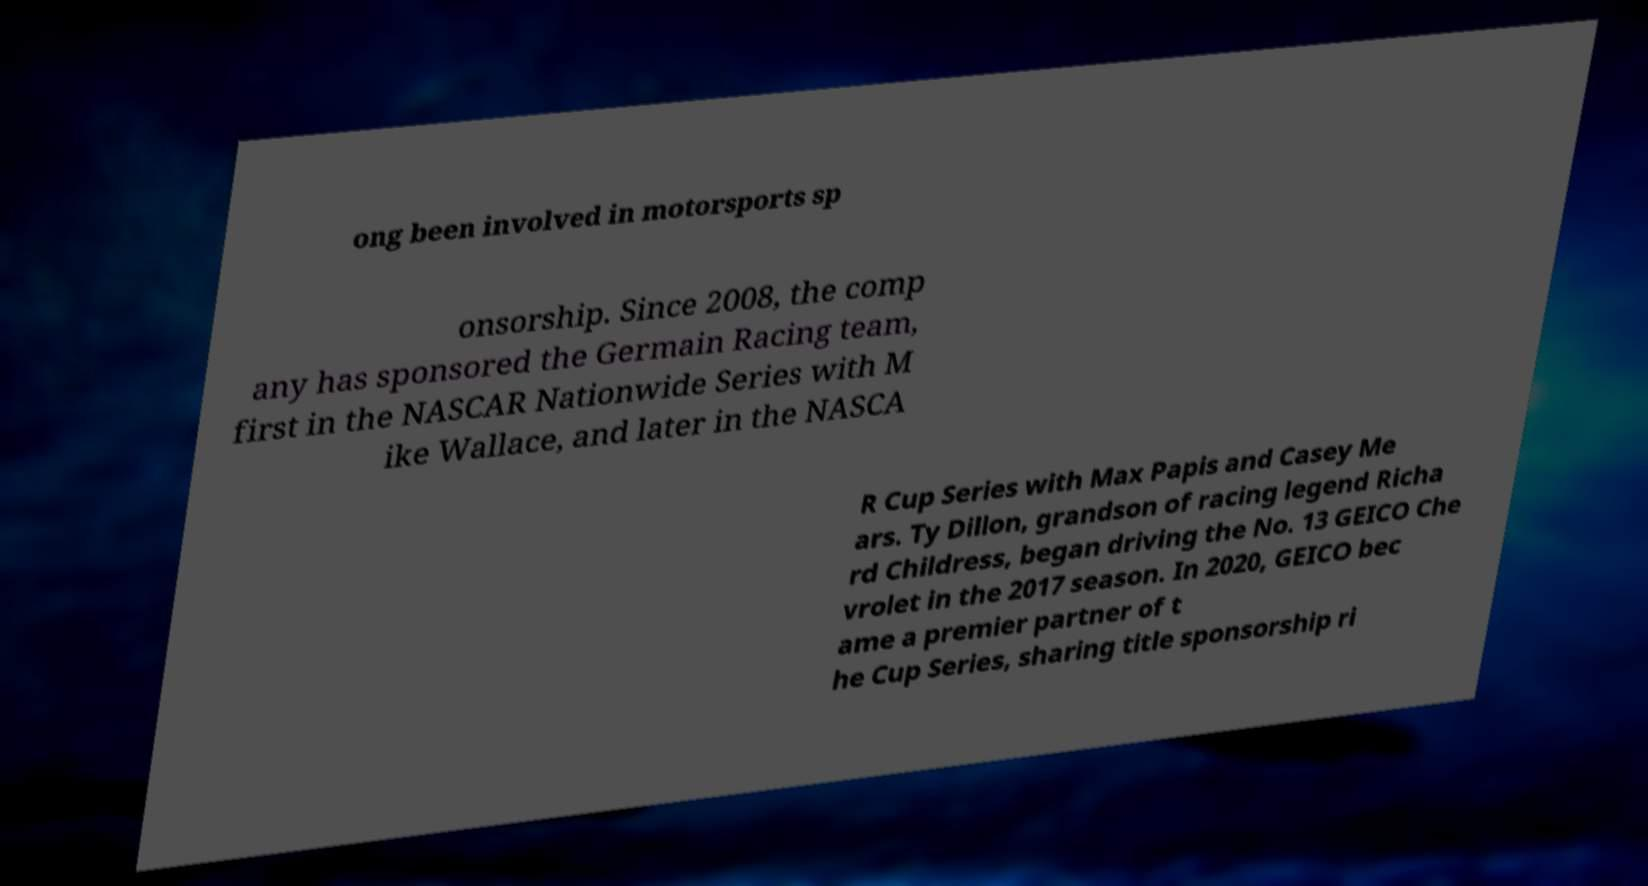Can you accurately transcribe the text from the provided image for me? ong been involved in motorsports sp onsorship. Since 2008, the comp any has sponsored the Germain Racing team, first in the NASCAR Nationwide Series with M ike Wallace, and later in the NASCA R Cup Series with Max Papis and Casey Me ars. Ty Dillon, grandson of racing legend Richa rd Childress, began driving the No. 13 GEICO Che vrolet in the 2017 season. In 2020, GEICO bec ame a premier partner of t he Cup Series, sharing title sponsorship ri 